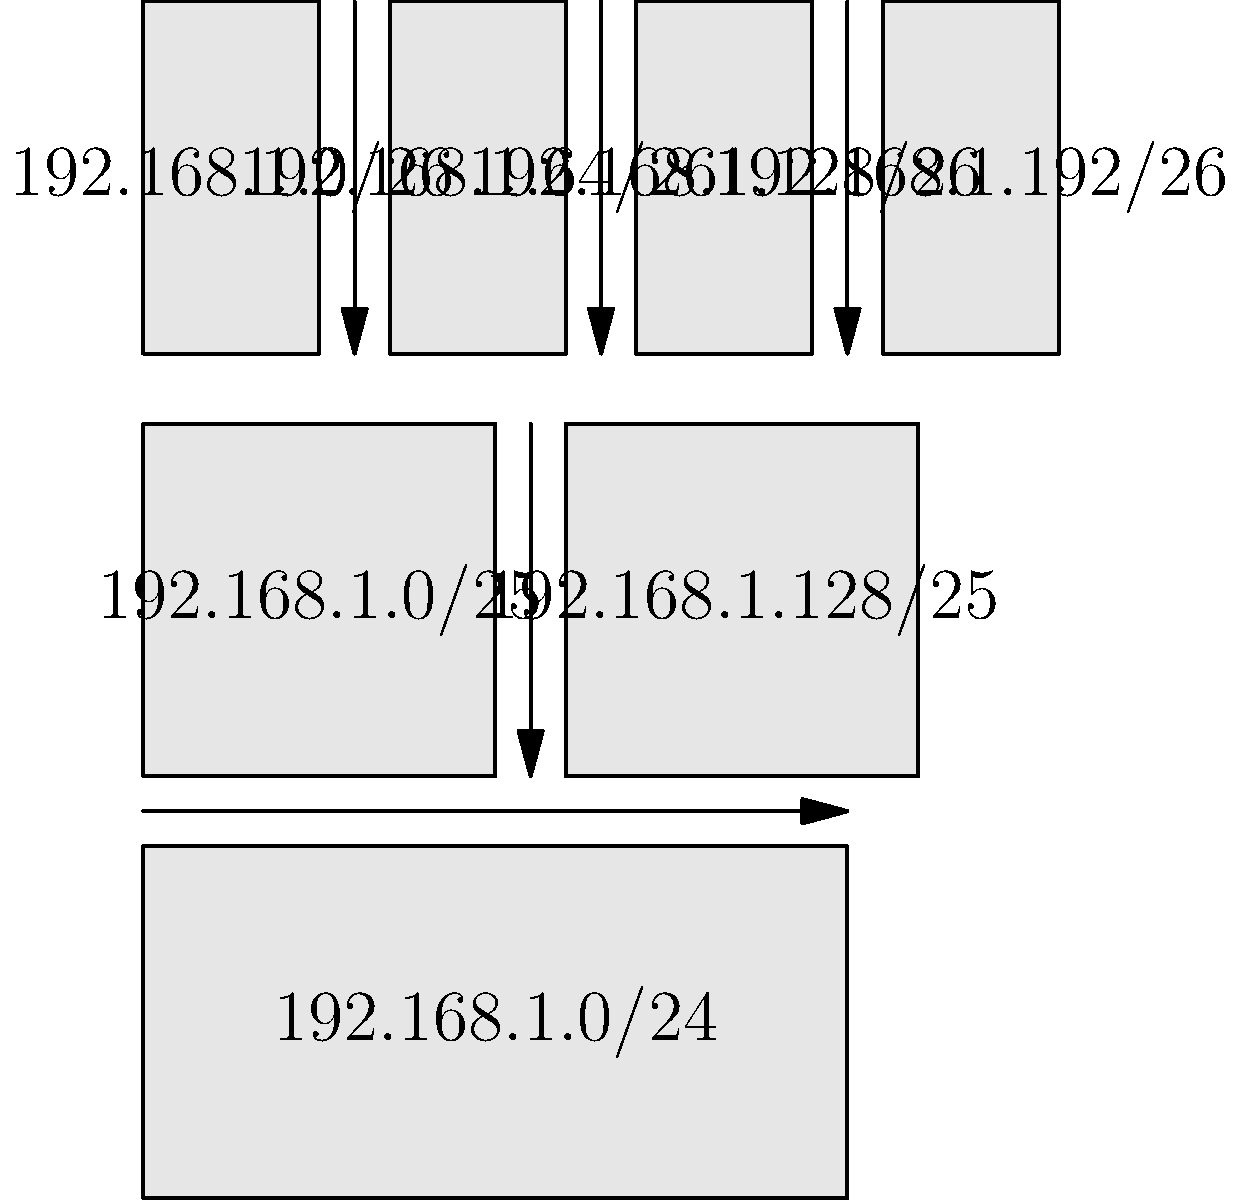In our home network, we're planning to set up different subnets for various devices. If we start with the network 192.168.1.0/24 and want to create four equal-sized subnets, what will be the subnet mask for each of these subnets? (Hint: Look at the bottom row of the diagram) Let's break this down step-by-step, as if we're explaining it during a sing-along session:

1) We start with the network 192.168.1.0/24. The /24 means that the first 24 bits are used for the network portion, leaving 8 bits for host addresses.

2) To create four equal-sized subnets, we need to "borrow" 2 more bits from the host portion. Why? Because $2^2 = 4$, which gives us our desired number of subnets.

3) Adding these 2 bits to the original 24 gives us a new subnet mask of /26.

4) In binary, a /26 subnet mask looks like this:
   11111111.11111111.11111111.11000000

5) Converting this to decimal, we get:
   255.255.255.192

6) Looking at the bottom row of our diagram, we can see that indeed, we have four subnets, each with a /26 mask:
   192.168.1.0/26
   192.168.1.64/26
   192.168.1.128/26
   192.168.1.192/26

7) Each of these subnets has 64 possible host addresses ($2^6 = 64$, because we have 6 bits left for the host portion).

So, just like how we remember lyrics to our favorite songs, we can remember that to create 4 subnets, we add 2 bits to our original subnet mask!
Answer: 255.255.255.192 